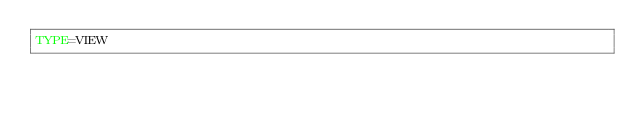<code> <loc_0><loc_0><loc_500><loc_500><_VisualBasic_>TYPE=VIEW</code> 